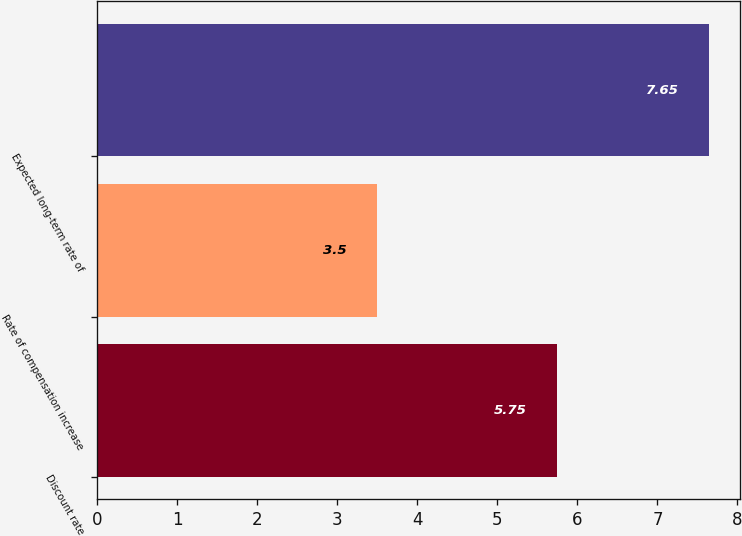Convert chart to OTSL. <chart><loc_0><loc_0><loc_500><loc_500><bar_chart><fcel>Discount rate<fcel>Rate of compensation increase<fcel>Expected long-term rate of<nl><fcel>5.75<fcel>3.5<fcel>7.65<nl></chart> 